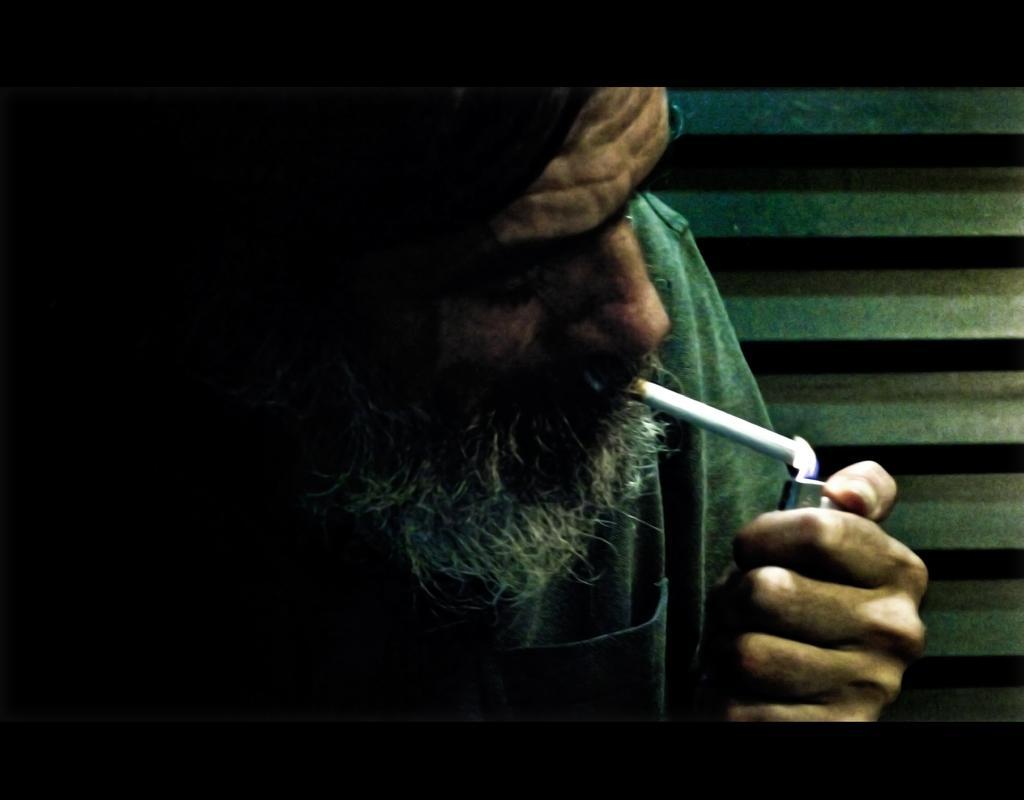Please provide a concise description of this image. In this image there is a man with a cigarette in his mouth and he is lighting a cigarette with a lighter. In the background there is a wall. 